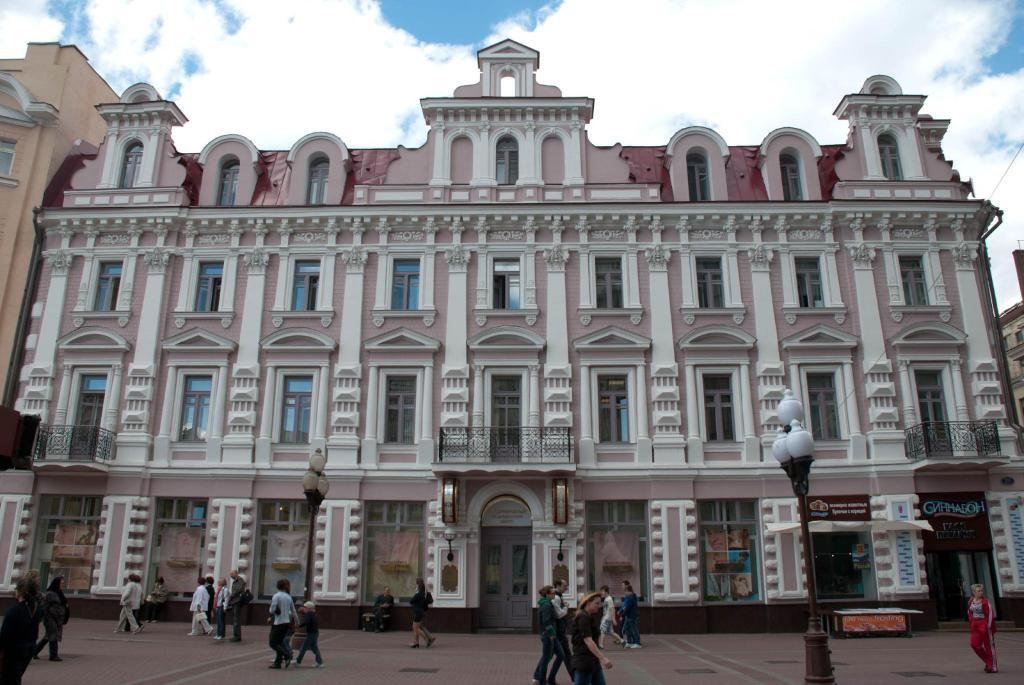What is the main subject in the center of the image? There are buildings in the center of the image. What activity can be seen at the bottom of the image? There are people walking at the bottom of the image. What type of structures are visible in the image? There are poles visible in the image. What is visible at the top of the image? The sky is visible at the top of the image. How many chairs can be seen bursting into flames in the image? There are no chairs present in the image, let alone any chairs bursting into flames. 